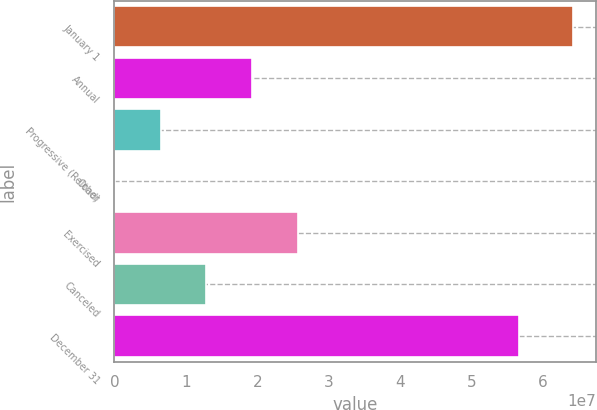Convert chart to OTSL. <chart><loc_0><loc_0><loc_500><loc_500><bar_chart><fcel>January 1<fcel>Annual<fcel>Progressive (Reload)<fcel>Other<fcel>Exercised<fcel>Canceled<fcel>December 31<nl><fcel>6.41484e+07<fcel>1.92807e+07<fcel>6.46134e+06<fcel>51661<fcel>2.56904e+07<fcel>1.2871e+07<fcel>5.6565e+07<nl></chart> 